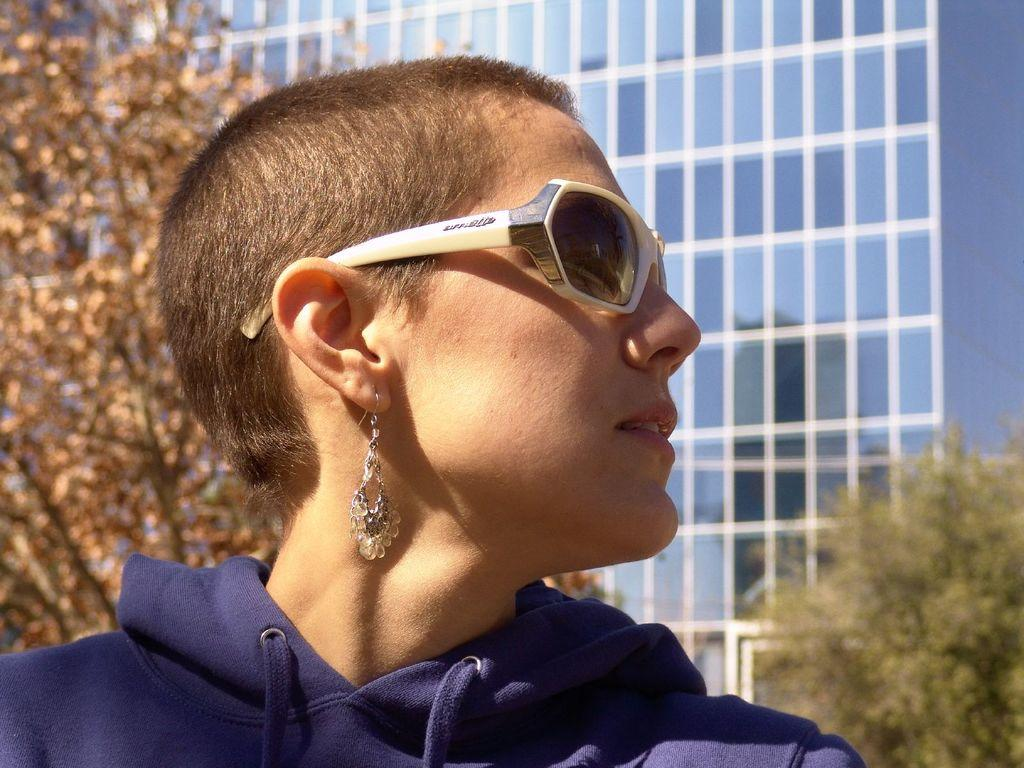Who is present in the image? There is a woman in the image. What is the woman wearing on her face? The woman is wearing sunglasses. What can be seen in the background of the image? There is a building and trees in the background of the image. What rhythm is the woman dancing to in the image? There is no indication in the image that the woman is dancing, and therefore no rhythm can be determined. 